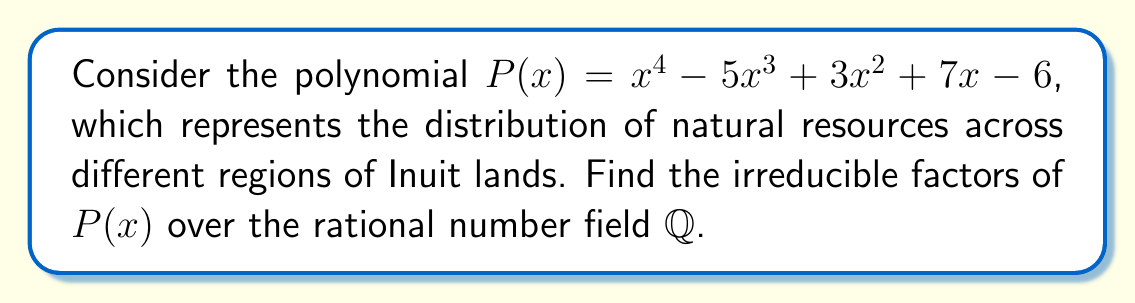Help me with this question. To find the irreducible factors of $P(x)$ over $\mathbb{Q}$, we'll follow these steps:

1) First, check for rational roots using the rational root theorem. The possible rational roots are the factors of the constant term: $\pm 1, \pm 2, \pm 3, \pm 6$.

2) Testing these values, we find that $x = 1$ and $x = 2$ are roots of $P(x)$.

3) Divide $P(x)$ by $(x-1)$ and $(x-2)$:

   $$P(x) = (x-1)(x-2)(x^2 - 2x - 3)$$

4) The quadratic factor $x^2 - 2x - 3$ can be factored further:

   $$x^2 - 2x - 3 = (x-3)(x+1)$$

5) Therefore, the complete factorization is:

   $$P(x) = (x-1)(x-2)(x-3)(x+1)$$

6) Each of these linear factors is irreducible over $\mathbb{Q}$.

This factorization represents how the natural resources are distributed across four distinct regions of Inuit lands, each corresponding to a root of the polynomial.
Answer: $(x-1)(x-2)(x-3)(x+1)$ 